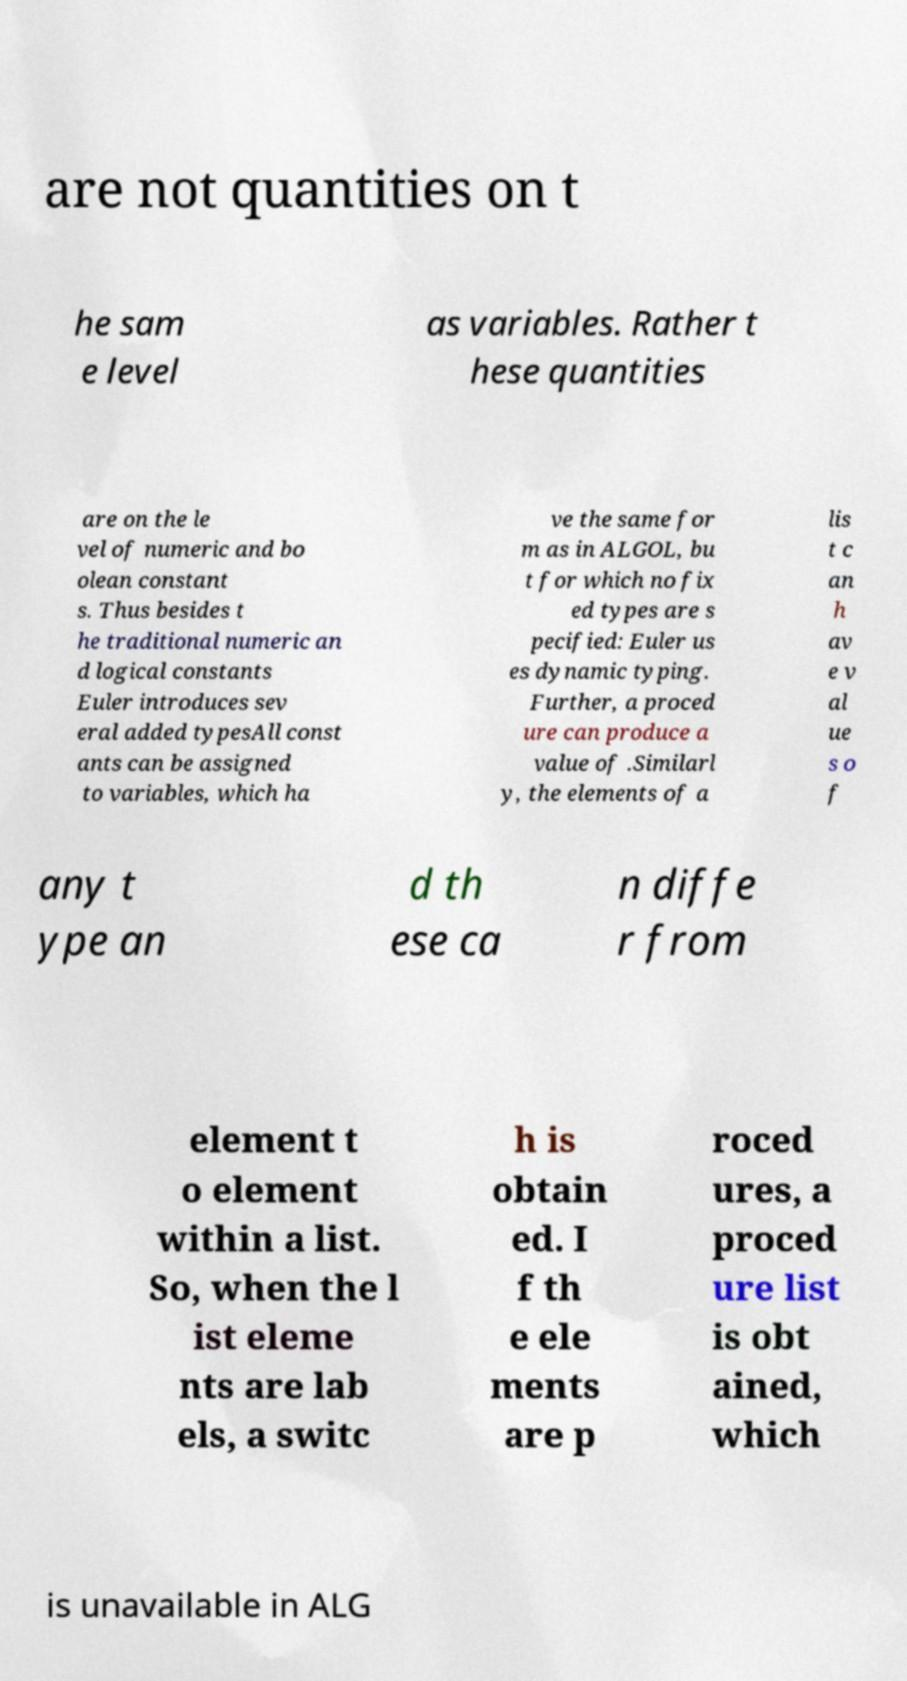What messages or text are displayed in this image? I need them in a readable, typed format. are not quantities on t he sam e level as variables. Rather t hese quantities are on the le vel of numeric and bo olean constant s. Thus besides t he traditional numeric an d logical constants Euler introduces sev eral added typesAll const ants can be assigned to variables, which ha ve the same for m as in ALGOL, bu t for which no fix ed types are s pecified: Euler us es dynamic typing. Further, a proced ure can produce a value of .Similarl y, the elements of a lis t c an h av e v al ue s o f any t ype an d th ese ca n diffe r from element t o element within a list. So, when the l ist eleme nts are lab els, a switc h is obtain ed. I f th e ele ments are p roced ures, a proced ure list is obt ained, which is unavailable in ALG 